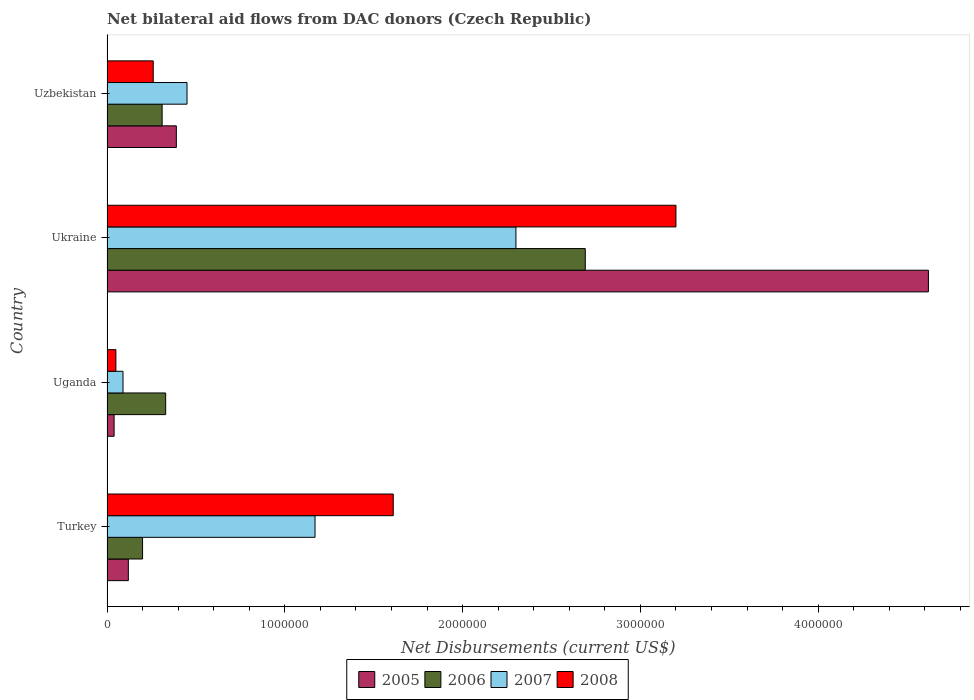How many different coloured bars are there?
Provide a short and direct response. 4. Are the number of bars on each tick of the Y-axis equal?
Ensure brevity in your answer.  Yes. How many bars are there on the 3rd tick from the top?
Your answer should be compact. 4. What is the label of the 1st group of bars from the top?
Offer a very short reply. Uzbekistan. In how many cases, is the number of bars for a given country not equal to the number of legend labels?
Provide a short and direct response. 0. What is the net bilateral aid flows in 2007 in Uganda?
Provide a succinct answer. 9.00e+04. Across all countries, what is the maximum net bilateral aid flows in 2007?
Ensure brevity in your answer.  2.30e+06. In which country was the net bilateral aid flows in 2007 maximum?
Offer a terse response. Ukraine. In which country was the net bilateral aid flows in 2007 minimum?
Your answer should be compact. Uganda. What is the total net bilateral aid flows in 2005 in the graph?
Provide a short and direct response. 5.17e+06. What is the difference between the net bilateral aid flows in 2005 in Uganda and that in Uzbekistan?
Keep it short and to the point. -3.50e+05. What is the average net bilateral aid flows in 2008 per country?
Keep it short and to the point. 1.28e+06. In how many countries, is the net bilateral aid flows in 2007 greater than 1200000 US$?
Keep it short and to the point. 1. What is the ratio of the net bilateral aid flows in 2006 in Turkey to that in Uzbekistan?
Give a very brief answer. 0.65. Is the difference between the net bilateral aid flows in 2006 in Ukraine and Uzbekistan greater than the difference between the net bilateral aid flows in 2005 in Ukraine and Uzbekistan?
Your answer should be very brief. No. What is the difference between the highest and the second highest net bilateral aid flows in 2006?
Make the answer very short. 2.36e+06. What is the difference between the highest and the lowest net bilateral aid flows in 2008?
Offer a terse response. 3.15e+06. In how many countries, is the net bilateral aid flows in 2006 greater than the average net bilateral aid flows in 2006 taken over all countries?
Your answer should be compact. 1. Is it the case that in every country, the sum of the net bilateral aid flows in 2007 and net bilateral aid flows in 2005 is greater than the sum of net bilateral aid flows in 2008 and net bilateral aid flows in 2006?
Make the answer very short. No. What does the 4th bar from the top in Uganda represents?
Your answer should be compact. 2005. What does the 1st bar from the bottom in Uganda represents?
Provide a short and direct response. 2005. How many bars are there?
Provide a short and direct response. 16. Are all the bars in the graph horizontal?
Offer a very short reply. Yes. Does the graph contain any zero values?
Provide a succinct answer. No. What is the title of the graph?
Offer a very short reply. Net bilateral aid flows from DAC donors (Czech Republic). What is the label or title of the X-axis?
Offer a very short reply. Net Disbursements (current US$). What is the label or title of the Y-axis?
Provide a short and direct response. Country. What is the Net Disbursements (current US$) in 2007 in Turkey?
Your response must be concise. 1.17e+06. What is the Net Disbursements (current US$) in 2008 in Turkey?
Provide a short and direct response. 1.61e+06. What is the Net Disbursements (current US$) of 2005 in Uganda?
Give a very brief answer. 4.00e+04. What is the Net Disbursements (current US$) of 2008 in Uganda?
Offer a very short reply. 5.00e+04. What is the Net Disbursements (current US$) in 2005 in Ukraine?
Your answer should be compact. 4.62e+06. What is the Net Disbursements (current US$) of 2006 in Ukraine?
Provide a short and direct response. 2.69e+06. What is the Net Disbursements (current US$) of 2007 in Ukraine?
Offer a very short reply. 2.30e+06. What is the Net Disbursements (current US$) in 2008 in Ukraine?
Keep it short and to the point. 3.20e+06. What is the Net Disbursements (current US$) in 2006 in Uzbekistan?
Provide a succinct answer. 3.10e+05. What is the Net Disbursements (current US$) in 2008 in Uzbekistan?
Your answer should be compact. 2.60e+05. Across all countries, what is the maximum Net Disbursements (current US$) of 2005?
Offer a terse response. 4.62e+06. Across all countries, what is the maximum Net Disbursements (current US$) in 2006?
Provide a short and direct response. 2.69e+06. Across all countries, what is the maximum Net Disbursements (current US$) in 2007?
Your response must be concise. 2.30e+06. Across all countries, what is the maximum Net Disbursements (current US$) of 2008?
Offer a terse response. 3.20e+06. Across all countries, what is the minimum Net Disbursements (current US$) in 2007?
Offer a terse response. 9.00e+04. Across all countries, what is the minimum Net Disbursements (current US$) in 2008?
Provide a short and direct response. 5.00e+04. What is the total Net Disbursements (current US$) in 2005 in the graph?
Provide a short and direct response. 5.17e+06. What is the total Net Disbursements (current US$) of 2006 in the graph?
Offer a terse response. 3.53e+06. What is the total Net Disbursements (current US$) of 2007 in the graph?
Provide a short and direct response. 4.01e+06. What is the total Net Disbursements (current US$) in 2008 in the graph?
Offer a terse response. 5.12e+06. What is the difference between the Net Disbursements (current US$) in 2005 in Turkey and that in Uganda?
Ensure brevity in your answer.  8.00e+04. What is the difference between the Net Disbursements (current US$) of 2006 in Turkey and that in Uganda?
Keep it short and to the point. -1.30e+05. What is the difference between the Net Disbursements (current US$) in 2007 in Turkey and that in Uganda?
Ensure brevity in your answer.  1.08e+06. What is the difference between the Net Disbursements (current US$) in 2008 in Turkey and that in Uganda?
Keep it short and to the point. 1.56e+06. What is the difference between the Net Disbursements (current US$) in 2005 in Turkey and that in Ukraine?
Your response must be concise. -4.50e+06. What is the difference between the Net Disbursements (current US$) in 2006 in Turkey and that in Ukraine?
Ensure brevity in your answer.  -2.49e+06. What is the difference between the Net Disbursements (current US$) in 2007 in Turkey and that in Ukraine?
Provide a succinct answer. -1.13e+06. What is the difference between the Net Disbursements (current US$) of 2008 in Turkey and that in Ukraine?
Offer a very short reply. -1.59e+06. What is the difference between the Net Disbursements (current US$) of 2006 in Turkey and that in Uzbekistan?
Provide a succinct answer. -1.10e+05. What is the difference between the Net Disbursements (current US$) of 2007 in Turkey and that in Uzbekistan?
Keep it short and to the point. 7.20e+05. What is the difference between the Net Disbursements (current US$) in 2008 in Turkey and that in Uzbekistan?
Make the answer very short. 1.35e+06. What is the difference between the Net Disbursements (current US$) of 2005 in Uganda and that in Ukraine?
Provide a short and direct response. -4.58e+06. What is the difference between the Net Disbursements (current US$) of 2006 in Uganda and that in Ukraine?
Provide a short and direct response. -2.36e+06. What is the difference between the Net Disbursements (current US$) in 2007 in Uganda and that in Ukraine?
Make the answer very short. -2.21e+06. What is the difference between the Net Disbursements (current US$) in 2008 in Uganda and that in Ukraine?
Your response must be concise. -3.15e+06. What is the difference between the Net Disbursements (current US$) in 2005 in Uganda and that in Uzbekistan?
Provide a short and direct response. -3.50e+05. What is the difference between the Net Disbursements (current US$) in 2006 in Uganda and that in Uzbekistan?
Give a very brief answer. 2.00e+04. What is the difference between the Net Disbursements (current US$) in 2007 in Uganda and that in Uzbekistan?
Your answer should be compact. -3.60e+05. What is the difference between the Net Disbursements (current US$) of 2005 in Ukraine and that in Uzbekistan?
Offer a very short reply. 4.23e+06. What is the difference between the Net Disbursements (current US$) in 2006 in Ukraine and that in Uzbekistan?
Your answer should be compact. 2.38e+06. What is the difference between the Net Disbursements (current US$) of 2007 in Ukraine and that in Uzbekistan?
Make the answer very short. 1.85e+06. What is the difference between the Net Disbursements (current US$) in 2008 in Ukraine and that in Uzbekistan?
Make the answer very short. 2.94e+06. What is the difference between the Net Disbursements (current US$) in 2005 in Turkey and the Net Disbursements (current US$) in 2006 in Uganda?
Your response must be concise. -2.10e+05. What is the difference between the Net Disbursements (current US$) in 2005 in Turkey and the Net Disbursements (current US$) in 2007 in Uganda?
Ensure brevity in your answer.  3.00e+04. What is the difference between the Net Disbursements (current US$) of 2006 in Turkey and the Net Disbursements (current US$) of 2008 in Uganda?
Offer a terse response. 1.50e+05. What is the difference between the Net Disbursements (current US$) of 2007 in Turkey and the Net Disbursements (current US$) of 2008 in Uganda?
Keep it short and to the point. 1.12e+06. What is the difference between the Net Disbursements (current US$) of 2005 in Turkey and the Net Disbursements (current US$) of 2006 in Ukraine?
Your answer should be compact. -2.57e+06. What is the difference between the Net Disbursements (current US$) in 2005 in Turkey and the Net Disbursements (current US$) in 2007 in Ukraine?
Offer a very short reply. -2.18e+06. What is the difference between the Net Disbursements (current US$) in 2005 in Turkey and the Net Disbursements (current US$) in 2008 in Ukraine?
Offer a terse response. -3.08e+06. What is the difference between the Net Disbursements (current US$) of 2006 in Turkey and the Net Disbursements (current US$) of 2007 in Ukraine?
Give a very brief answer. -2.10e+06. What is the difference between the Net Disbursements (current US$) of 2006 in Turkey and the Net Disbursements (current US$) of 2008 in Ukraine?
Give a very brief answer. -3.00e+06. What is the difference between the Net Disbursements (current US$) in 2007 in Turkey and the Net Disbursements (current US$) in 2008 in Ukraine?
Your response must be concise. -2.03e+06. What is the difference between the Net Disbursements (current US$) in 2005 in Turkey and the Net Disbursements (current US$) in 2006 in Uzbekistan?
Your answer should be very brief. -1.90e+05. What is the difference between the Net Disbursements (current US$) in 2005 in Turkey and the Net Disbursements (current US$) in 2007 in Uzbekistan?
Provide a succinct answer. -3.30e+05. What is the difference between the Net Disbursements (current US$) in 2006 in Turkey and the Net Disbursements (current US$) in 2008 in Uzbekistan?
Provide a succinct answer. -6.00e+04. What is the difference between the Net Disbursements (current US$) in 2007 in Turkey and the Net Disbursements (current US$) in 2008 in Uzbekistan?
Provide a short and direct response. 9.10e+05. What is the difference between the Net Disbursements (current US$) in 2005 in Uganda and the Net Disbursements (current US$) in 2006 in Ukraine?
Your response must be concise. -2.65e+06. What is the difference between the Net Disbursements (current US$) of 2005 in Uganda and the Net Disbursements (current US$) of 2007 in Ukraine?
Give a very brief answer. -2.26e+06. What is the difference between the Net Disbursements (current US$) in 2005 in Uganda and the Net Disbursements (current US$) in 2008 in Ukraine?
Provide a succinct answer. -3.16e+06. What is the difference between the Net Disbursements (current US$) in 2006 in Uganda and the Net Disbursements (current US$) in 2007 in Ukraine?
Offer a terse response. -1.97e+06. What is the difference between the Net Disbursements (current US$) of 2006 in Uganda and the Net Disbursements (current US$) of 2008 in Ukraine?
Keep it short and to the point. -2.87e+06. What is the difference between the Net Disbursements (current US$) in 2007 in Uganda and the Net Disbursements (current US$) in 2008 in Ukraine?
Give a very brief answer. -3.11e+06. What is the difference between the Net Disbursements (current US$) in 2005 in Uganda and the Net Disbursements (current US$) in 2006 in Uzbekistan?
Make the answer very short. -2.70e+05. What is the difference between the Net Disbursements (current US$) of 2005 in Uganda and the Net Disbursements (current US$) of 2007 in Uzbekistan?
Provide a short and direct response. -4.10e+05. What is the difference between the Net Disbursements (current US$) in 2006 in Uganda and the Net Disbursements (current US$) in 2007 in Uzbekistan?
Provide a short and direct response. -1.20e+05. What is the difference between the Net Disbursements (current US$) of 2006 in Uganda and the Net Disbursements (current US$) of 2008 in Uzbekistan?
Offer a terse response. 7.00e+04. What is the difference between the Net Disbursements (current US$) of 2007 in Uganda and the Net Disbursements (current US$) of 2008 in Uzbekistan?
Offer a terse response. -1.70e+05. What is the difference between the Net Disbursements (current US$) in 2005 in Ukraine and the Net Disbursements (current US$) in 2006 in Uzbekistan?
Offer a terse response. 4.31e+06. What is the difference between the Net Disbursements (current US$) of 2005 in Ukraine and the Net Disbursements (current US$) of 2007 in Uzbekistan?
Provide a short and direct response. 4.17e+06. What is the difference between the Net Disbursements (current US$) of 2005 in Ukraine and the Net Disbursements (current US$) of 2008 in Uzbekistan?
Your answer should be compact. 4.36e+06. What is the difference between the Net Disbursements (current US$) of 2006 in Ukraine and the Net Disbursements (current US$) of 2007 in Uzbekistan?
Provide a short and direct response. 2.24e+06. What is the difference between the Net Disbursements (current US$) of 2006 in Ukraine and the Net Disbursements (current US$) of 2008 in Uzbekistan?
Provide a short and direct response. 2.43e+06. What is the difference between the Net Disbursements (current US$) of 2007 in Ukraine and the Net Disbursements (current US$) of 2008 in Uzbekistan?
Your answer should be compact. 2.04e+06. What is the average Net Disbursements (current US$) in 2005 per country?
Your answer should be very brief. 1.29e+06. What is the average Net Disbursements (current US$) in 2006 per country?
Ensure brevity in your answer.  8.82e+05. What is the average Net Disbursements (current US$) in 2007 per country?
Provide a short and direct response. 1.00e+06. What is the average Net Disbursements (current US$) in 2008 per country?
Offer a terse response. 1.28e+06. What is the difference between the Net Disbursements (current US$) of 2005 and Net Disbursements (current US$) of 2007 in Turkey?
Make the answer very short. -1.05e+06. What is the difference between the Net Disbursements (current US$) in 2005 and Net Disbursements (current US$) in 2008 in Turkey?
Ensure brevity in your answer.  -1.49e+06. What is the difference between the Net Disbursements (current US$) of 2006 and Net Disbursements (current US$) of 2007 in Turkey?
Give a very brief answer. -9.70e+05. What is the difference between the Net Disbursements (current US$) in 2006 and Net Disbursements (current US$) in 2008 in Turkey?
Provide a short and direct response. -1.41e+06. What is the difference between the Net Disbursements (current US$) of 2007 and Net Disbursements (current US$) of 2008 in Turkey?
Ensure brevity in your answer.  -4.40e+05. What is the difference between the Net Disbursements (current US$) in 2005 and Net Disbursements (current US$) in 2007 in Uganda?
Provide a succinct answer. -5.00e+04. What is the difference between the Net Disbursements (current US$) in 2007 and Net Disbursements (current US$) in 2008 in Uganda?
Your answer should be compact. 4.00e+04. What is the difference between the Net Disbursements (current US$) of 2005 and Net Disbursements (current US$) of 2006 in Ukraine?
Offer a very short reply. 1.93e+06. What is the difference between the Net Disbursements (current US$) in 2005 and Net Disbursements (current US$) in 2007 in Ukraine?
Your answer should be compact. 2.32e+06. What is the difference between the Net Disbursements (current US$) of 2005 and Net Disbursements (current US$) of 2008 in Ukraine?
Make the answer very short. 1.42e+06. What is the difference between the Net Disbursements (current US$) of 2006 and Net Disbursements (current US$) of 2008 in Ukraine?
Ensure brevity in your answer.  -5.10e+05. What is the difference between the Net Disbursements (current US$) in 2007 and Net Disbursements (current US$) in 2008 in Ukraine?
Make the answer very short. -9.00e+05. What is the difference between the Net Disbursements (current US$) in 2005 and Net Disbursements (current US$) in 2008 in Uzbekistan?
Your answer should be very brief. 1.30e+05. What is the ratio of the Net Disbursements (current US$) in 2006 in Turkey to that in Uganda?
Make the answer very short. 0.61. What is the ratio of the Net Disbursements (current US$) in 2007 in Turkey to that in Uganda?
Your answer should be compact. 13. What is the ratio of the Net Disbursements (current US$) of 2008 in Turkey to that in Uganda?
Your response must be concise. 32.2. What is the ratio of the Net Disbursements (current US$) of 2005 in Turkey to that in Ukraine?
Ensure brevity in your answer.  0.03. What is the ratio of the Net Disbursements (current US$) of 2006 in Turkey to that in Ukraine?
Offer a very short reply. 0.07. What is the ratio of the Net Disbursements (current US$) in 2007 in Turkey to that in Ukraine?
Offer a very short reply. 0.51. What is the ratio of the Net Disbursements (current US$) in 2008 in Turkey to that in Ukraine?
Your answer should be very brief. 0.5. What is the ratio of the Net Disbursements (current US$) of 2005 in Turkey to that in Uzbekistan?
Make the answer very short. 0.31. What is the ratio of the Net Disbursements (current US$) of 2006 in Turkey to that in Uzbekistan?
Give a very brief answer. 0.65. What is the ratio of the Net Disbursements (current US$) of 2007 in Turkey to that in Uzbekistan?
Give a very brief answer. 2.6. What is the ratio of the Net Disbursements (current US$) of 2008 in Turkey to that in Uzbekistan?
Ensure brevity in your answer.  6.19. What is the ratio of the Net Disbursements (current US$) of 2005 in Uganda to that in Ukraine?
Your answer should be compact. 0.01. What is the ratio of the Net Disbursements (current US$) in 2006 in Uganda to that in Ukraine?
Give a very brief answer. 0.12. What is the ratio of the Net Disbursements (current US$) of 2007 in Uganda to that in Ukraine?
Offer a terse response. 0.04. What is the ratio of the Net Disbursements (current US$) of 2008 in Uganda to that in Ukraine?
Your response must be concise. 0.02. What is the ratio of the Net Disbursements (current US$) in 2005 in Uganda to that in Uzbekistan?
Your answer should be compact. 0.1. What is the ratio of the Net Disbursements (current US$) in 2006 in Uganda to that in Uzbekistan?
Your answer should be very brief. 1.06. What is the ratio of the Net Disbursements (current US$) of 2007 in Uganda to that in Uzbekistan?
Your answer should be very brief. 0.2. What is the ratio of the Net Disbursements (current US$) of 2008 in Uganda to that in Uzbekistan?
Keep it short and to the point. 0.19. What is the ratio of the Net Disbursements (current US$) of 2005 in Ukraine to that in Uzbekistan?
Your answer should be compact. 11.85. What is the ratio of the Net Disbursements (current US$) in 2006 in Ukraine to that in Uzbekistan?
Ensure brevity in your answer.  8.68. What is the ratio of the Net Disbursements (current US$) of 2007 in Ukraine to that in Uzbekistan?
Your answer should be very brief. 5.11. What is the ratio of the Net Disbursements (current US$) of 2008 in Ukraine to that in Uzbekistan?
Your response must be concise. 12.31. What is the difference between the highest and the second highest Net Disbursements (current US$) in 2005?
Offer a terse response. 4.23e+06. What is the difference between the highest and the second highest Net Disbursements (current US$) of 2006?
Provide a succinct answer. 2.36e+06. What is the difference between the highest and the second highest Net Disbursements (current US$) of 2007?
Offer a very short reply. 1.13e+06. What is the difference between the highest and the second highest Net Disbursements (current US$) of 2008?
Ensure brevity in your answer.  1.59e+06. What is the difference between the highest and the lowest Net Disbursements (current US$) of 2005?
Your answer should be very brief. 4.58e+06. What is the difference between the highest and the lowest Net Disbursements (current US$) of 2006?
Make the answer very short. 2.49e+06. What is the difference between the highest and the lowest Net Disbursements (current US$) of 2007?
Offer a very short reply. 2.21e+06. What is the difference between the highest and the lowest Net Disbursements (current US$) in 2008?
Ensure brevity in your answer.  3.15e+06. 